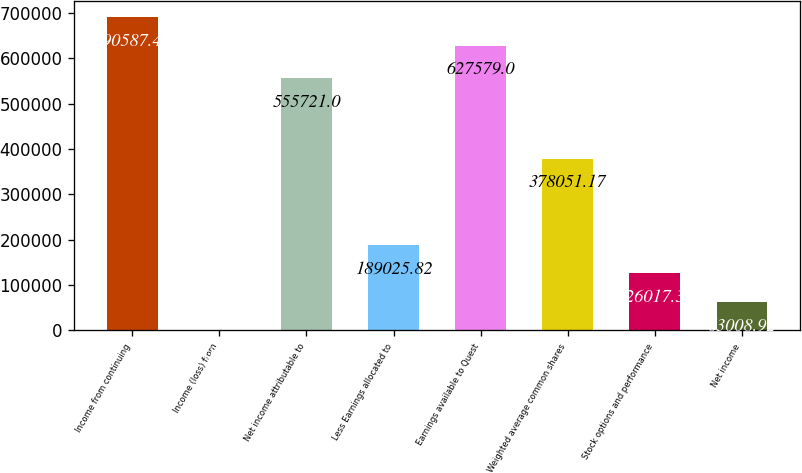Convert chart to OTSL. <chart><loc_0><loc_0><loc_500><loc_500><bar_chart><fcel>Income from continuing<fcel>Income (loss) from<fcel>Net income attributable to<fcel>Less Earnings allocated to<fcel>Earnings available to Quest<fcel>Weighted average common shares<fcel>Stock options and performance<fcel>Net income<nl><fcel>690587<fcel>0.47<fcel>555721<fcel>189026<fcel>627579<fcel>378051<fcel>126017<fcel>63008.9<nl></chart> 